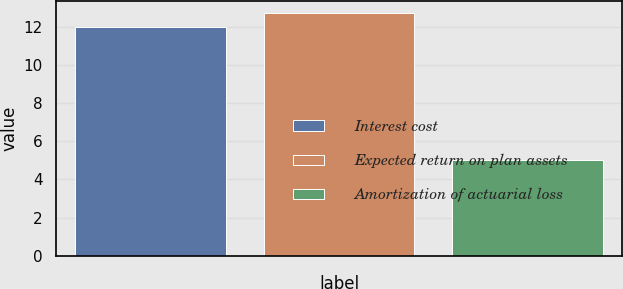<chart> <loc_0><loc_0><loc_500><loc_500><bar_chart><fcel>Interest cost<fcel>Expected return on plan assets<fcel>Amortization of actuarial loss<nl><fcel>12<fcel>12.7<fcel>5<nl></chart> 